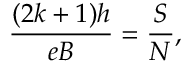Convert formula to latex. <formula><loc_0><loc_0><loc_500><loc_500>\frac { ( 2 k + 1 ) h } { e B } = \frac { S } { N } ,</formula> 